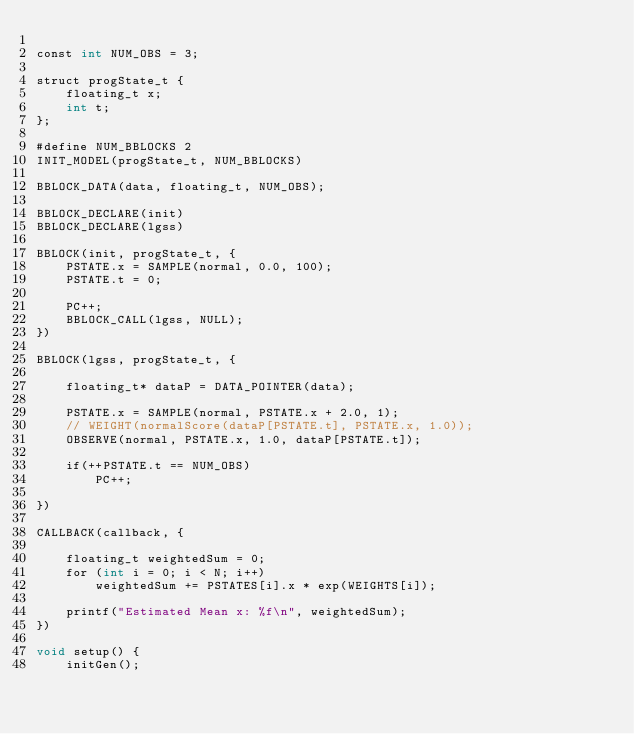Convert code to text. <code><loc_0><loc_0><loc_500><loc_500><_Cuda_>
const int NUM_OBS = 3;

struct progState_t {
    floating_t x;
    int t;
};

#define NUM_BBLOCKS 2
INIT_MODEL(progState_t, NUM_BBLOCKS)

BBLOCK_DATA(data, floating_t, NUM_OBS);

BBLOCK_DECLARE(init)
BBLOCK_DECLARE(lgss)

BBLOCK(init, progState_t, {
    PSTATE.x = SAMPLE(normal, 0.0, 100);
    PSTATE.t = 0;

    PC++;
    BBLOCK_CALL(lgss, NULL);
})

BBLOCK(lgss, progState_t, {

    floating_t* dataP = DATA_POINTER(data);
    
    PSTATE.x = SAMPLE(normal, PSTATE.x + 2.0, 1);
    // WEIGHT(normalScore(dataP[PSTATE.t], PSTATE.x, 1.0));
    OBSERVE(normal, PSTATE.x, 1.0, dataP[PSTATE.t]);

    if(++PSTATE.t == NUM_OBS)
        PC++;

})

CALLBACK(callback, {
    
    floating_t weightedSum = 0;
    for (int i = 0; i < N; i++)
        weightedSum += PSTATES[i].x * exp(WEIGHTS[i]);
        
    printf("Estimated Mean x: %f\n", weightedSum);
})

void setup() {
    initGen();</code> 